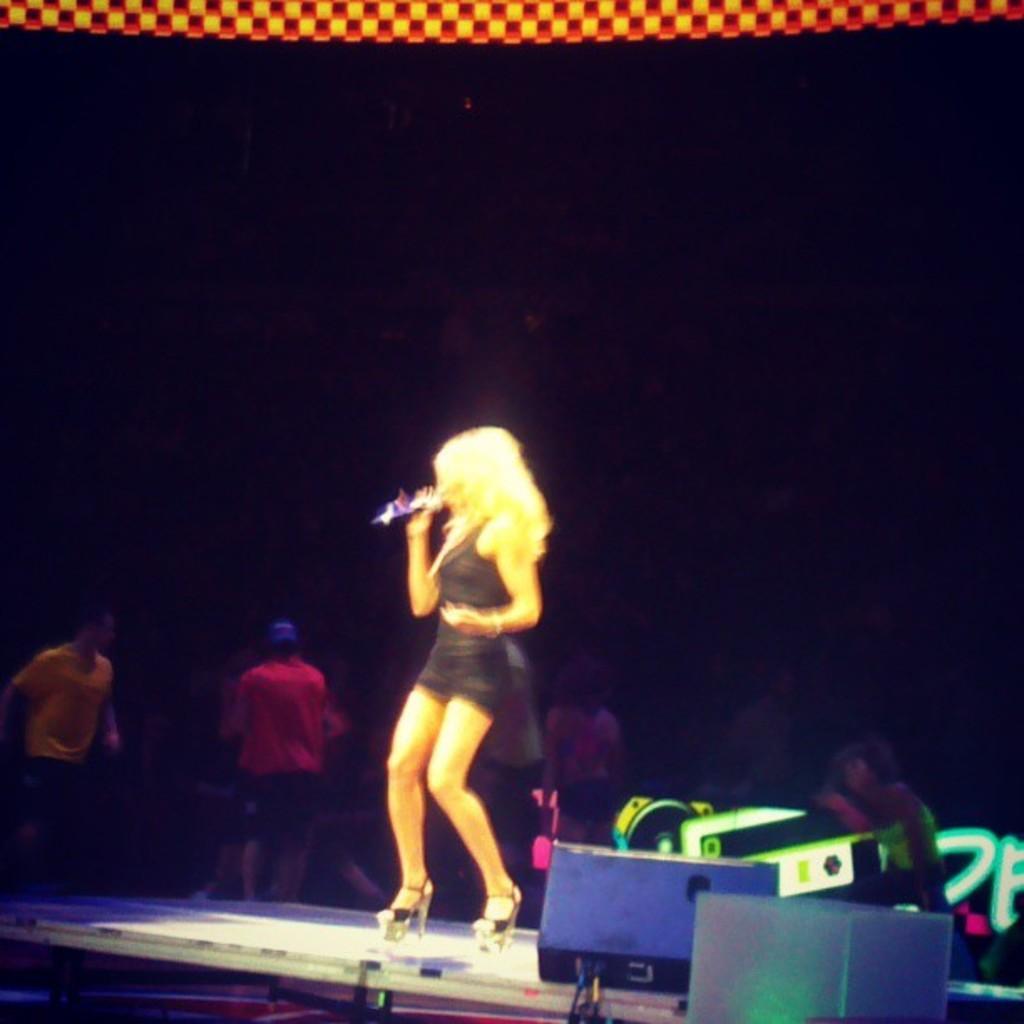Please provide a concise description of this image. In this picture I can see a woman standing on the dais and singing with the help of a microphone and I can see few people standing in the back and I can see dark background and looks like speakers on the dais. 